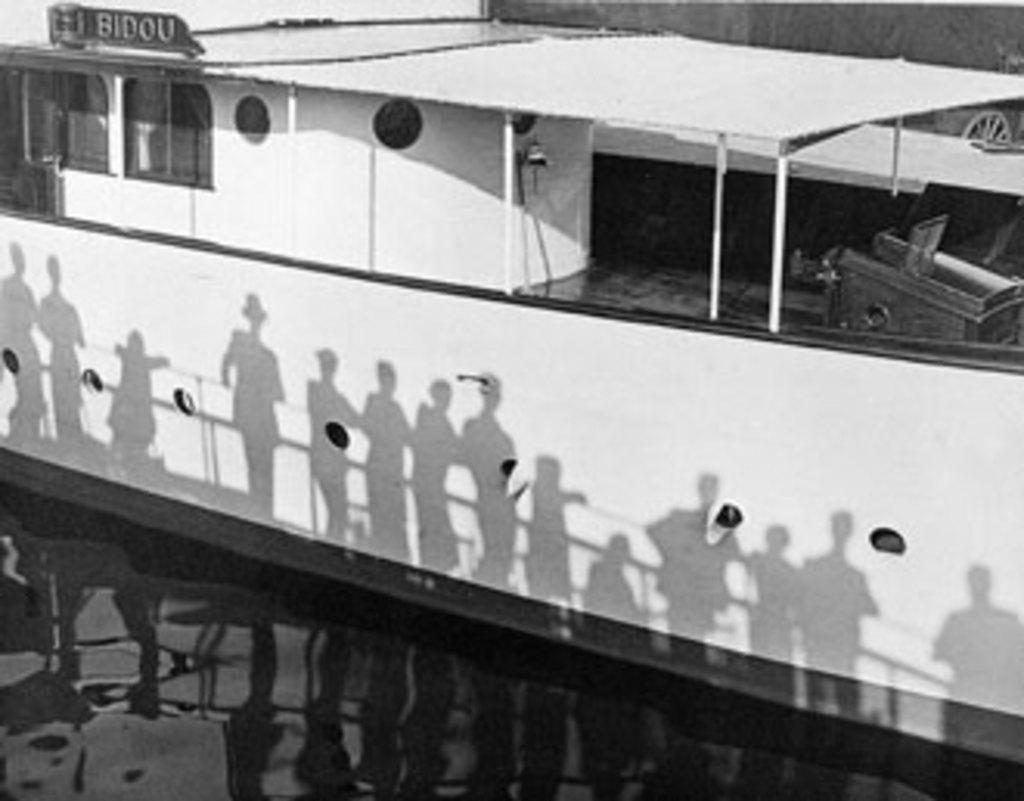<image>
Create a compact narrative representing the image presented. Shadows on a white boat that is called BIDOU 